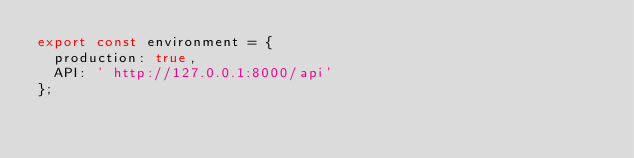<code> <loc_0><loc_0><loc_500><loc_500><_TypeScript_>export const environment = {
  production: true,
  API: ' http://127.0.0.1:8000/api'
};
</code> 